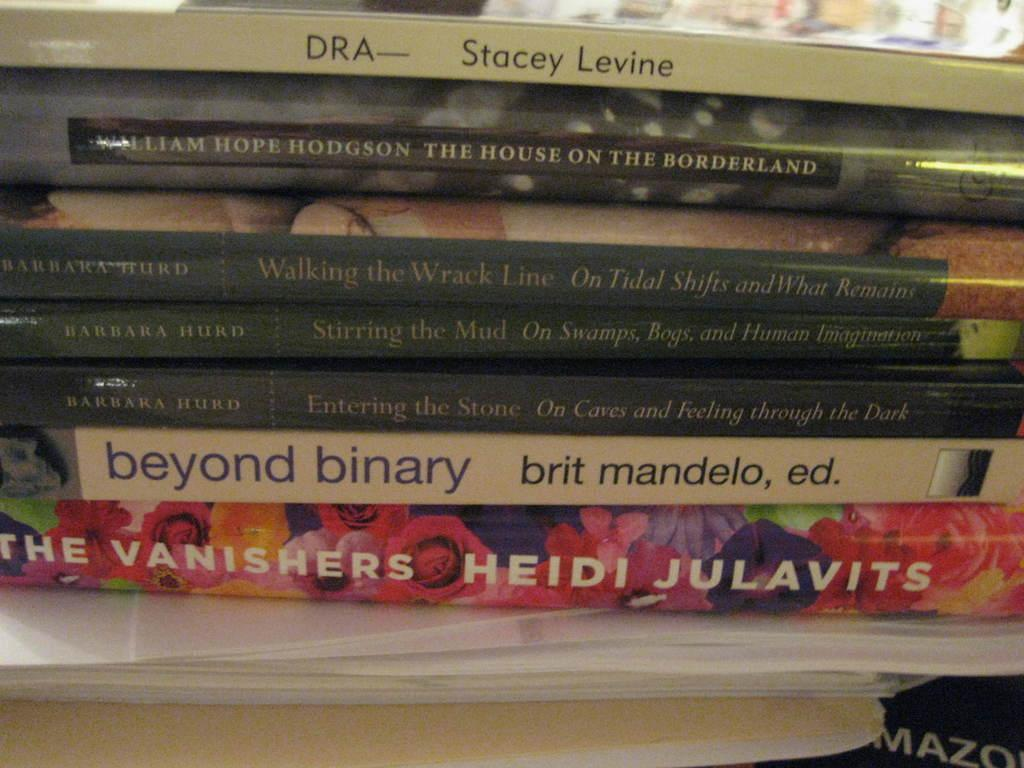<image>
Offer a succinct explanation of the picture presented. A colorful book titled The Vanishers by Heidi Julavits sits at the bottom of a stack of books 